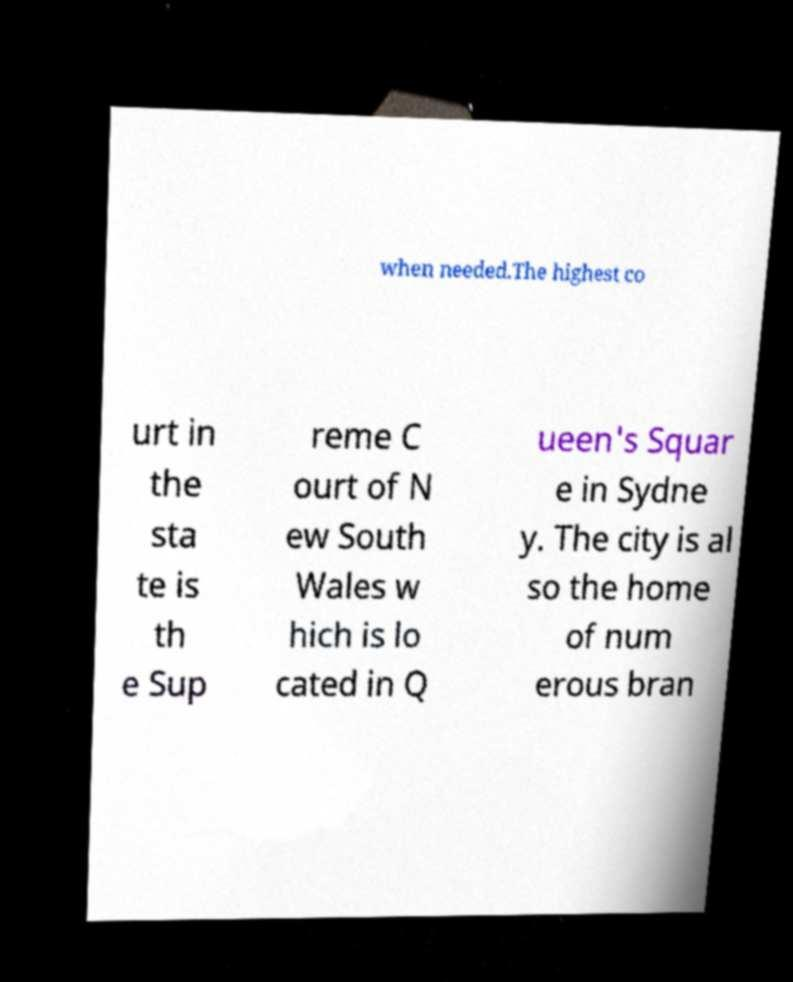What messages or text are displayed in this image? I need them in a readable, typed format. when needed.The highest co urt in the sta te is th e Sup reme C ourt of N ew South Wales w hich is lo cated in Q ueen's Squar e in Sydne y. The city is al so the home of num erous bran 